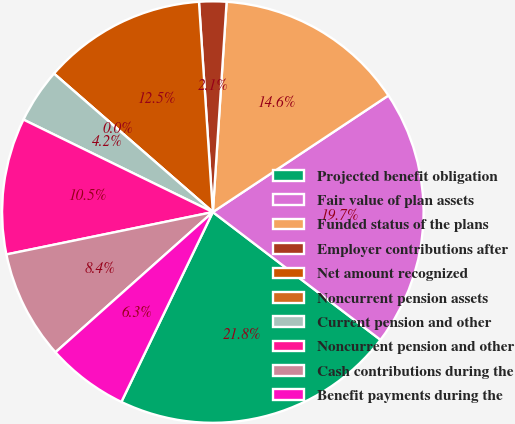Convert chart to OTSL. <chart><loc_0><loc_0><loc_500><loc_500><pie_chart><fcel>Projected benefit obligation<fcel>Fair value of plan assets<fcel>Funded status of the plans<fcel>Employer contributions after<fcel>Net amount recognized<fcel>Noncurrent pension assets<fcel>Current pension and other<fcel>Noncurrent pension and other<fcel>Cash contributions during the<fcel>Benefit payments during the<nl><fcel>21.78%<fcel>19.69%<fcel>14.63%<fcel>2.09%<fcel>12.54%<fcel>0.0%<fcel>4.18%<fcel>10.45%<fcel>8.36%<fcel>6.27%<nl></chart> 